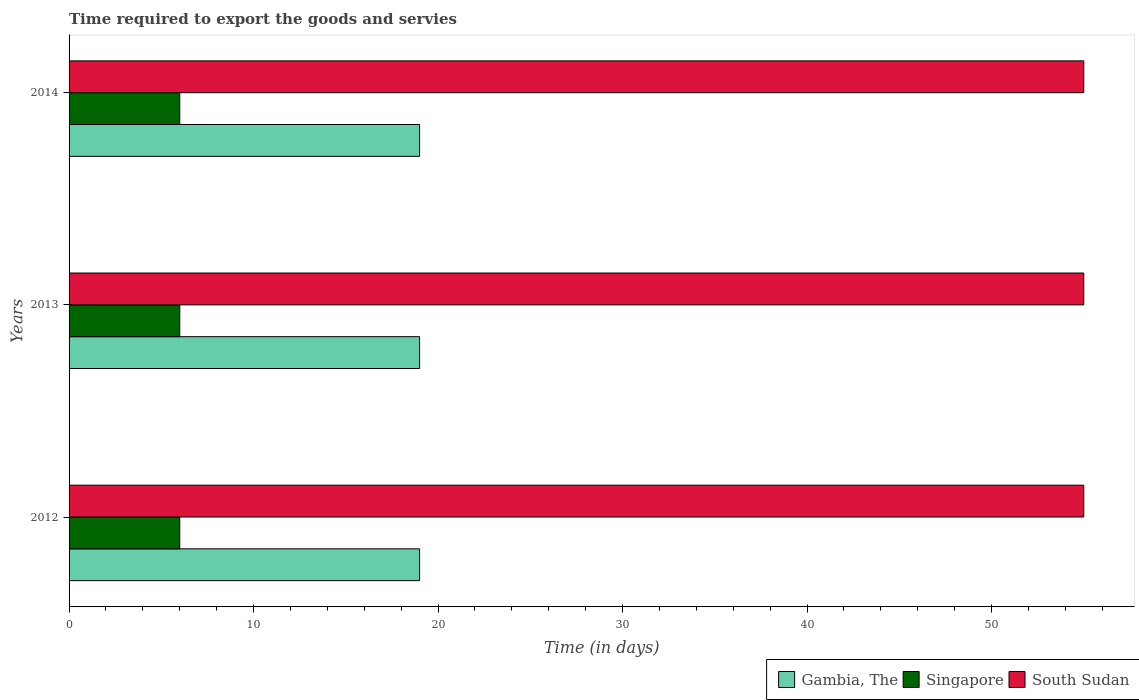How many different coloured bars are there?
Provide a succinct answer. 3. Are the number of bars per tick equal to the number of legend labels?
Give a very brief answer. Yes. Are the number of bars on each tick of the Y-axis equal?
Provide a succinct answer. Yes. How many bars are there on the 1st tick from the bottom?
Provide a short and direct response. 3. What is the label of the 2nd group of bars from the top?
Keep it short and to the point. 2013. What is the number of days required to export the goods and services in South Sudan in 2013?
Your response must be concise. 55. Across all years, what is the maximum number of days required to export the goods and services in Singapore?
Offer a very short reply. 6. Across all years, what is the minimum number of days required to export the goods and services in Singapore?
Keep it short and to the point. 6. In which year was the number of days required to export the goods and services in South Sudan maximum?
Offer a very short reply. 2012. What is the total number of days required to export the goods and services in Gambia, The in the graph?
Provide a short and direct response. 57. What is the difference between the number of days required to export the goods and services in Singapore in 2012 and that in 2013?
Your answer should be compact. 0. What is the difference between the number of days required to export the goods and services in Gambia, The in 2014 and the number of days required to export the goods and services in South Sudan in 2012?
Offer a very short reply. -36. In the year 2012, what is the difference between the number of days required to export the goods and services in Singapore and number of days required to export the goods and services in South Sudan?
Offer a terse response. -49. Is the number of days required to export the goods and services in Singapore in 2013 less than that in 2014?
Your response must be concise. No. What is the difference between the highest and the second highest number of days required to export the goods and services in Singapore?
Ensure brevity in your answer.  0. What is the difference between the highest and the lowest number of days required to export the goods and services in Singapore?
Make the answer very short. 0. What does the 1st bar from the top in 2014 represents?
Give a very brief answer. South Sudan. What does the 2nd bar from the bottom in 2012 represents?
Offer a very short reply. Singapore. Are all the bars in the graph horizontal?
Keep it short and to the point. Yes. How many years are there in the graph?
Give a very brief answer. 3. What is the difference between two consecutive major ticks on the X-axis?
Ensure brevity in your answer.  10. Are the values on the major ticks of X-axis written in scientific E-notation?
Ensure brevity in your answer.  No. Does the graph contain any zero values?
Ensure brevity in your answer.  No. Does the graph contain grids?
Offer a very short reply. No. How many legend labels are there?
Your answer should be compact. 3. How are the legend labels stacked?
Keep it short and to the point. Horizontal. What is the title of the graph?
Make the answer very short. Time required to export the goods and servies. Does "Mali" appear as one of the legend labels in the graph?
Your response must be concise. No. What is the label or title of the X-axis?
Offer a terse response. Time (in days). What is the label or title of the Y-axis?
Offer a terse response. Years. What is the Time (in days) of Singapore in 2012?
Ensure brevity in your answer.  6. What is the Time (in days) in South Sudan in 2012?
Your response must be concise. 55. What is the Time (in days) in Gambia, The in 2013?
Your answer should be compact. 19. What is the Time (in days) in South Sudan in 2013?
Offer a very short reply. 55. What is the Time (in days) in Gambia, The in 2014?
Offer a terse response. 19. What is the Time (in days) in South Sudan in 2014?
Offer a terse response. 55. Across all years, what is the maximum Time (in days) of Gambia, The?
Make the answer very short. 19. Across all years, what is the maximum Time (in days) of South Sudan?
Offer a terse response. 55. Across all years, what is the minimum Time (in days) in Singapore?
Provide a succinct answer. 6. Across all years, what is the minimum Time (in days) in South Sudan?
Your answer should be compact. 55. What is the total Time (in days) in South Sudan in the graph?
Your response must be concise. 165. What is the difference between the Time (in days) of Singapore in 2012 and that in 2013?
Give a very brief answer. 0. What is the difference between the Time (in days) of South Sudan in 2012 and that in 2013?
Make the answer very short. 0. What is the difference between the Time (in days) of Gambia, The in 2012 and that in 2014?
Your answer should be very brief. 0. What is the difference between the Time (in days) in Singapore in 2012 and that in 2014?
Your answer should be very brief. 0. What is the difference between the Time (in days) of South Sudan in 2013 and that in 2014?
Keep it short and to the point. 0. What is the difference between the Time (in days) of Gambia, The in 2012 and the Time (in days) of South Sudan in 2013?
Your answer should be very brief. -36. What is the difference between the Time (in days) of Singapore in 2012 and the Time (in days) of South Sudan in 2013?
Provide a succinct answer. -49. What is the difference between the Time (in days) in Gambia, The in 2012 and the Time (in days) in Singapore in 2014?
Give a very brief answer. 13. What is the difference between the Time (in days) in Gambia, The in 2012 and the Time (in days) in South Sudan in 2014?
Offer a terse response. -36. What is the difference between the Time (in days) of Singapore in 2012 and the Time (in days) of South Sudan in 2014?
Provide a succinct answer. -49. What is the difference between the Time (in days) in Gambia, The in 2013 and the Time (in days) in South Sudan in 2014?
Ensure brevity in your answer.  -36. What is the difference between the Time (in days) in Singapore in 2013 and the Time (in days) in South Sudan in 2014?
Offer a very short reply. -49. What is the average Time (in days) of Gambia, The per year?
Your response must be concise. 19. What is the average Time (in days) of Singapore per year?
Make the answer very short. 6. What is the average Time (in days) of South Sudan per year?
Offer a terse response. 55. In the year 2012, what is the difference between the Time (in days) in Gambia, The and Time (in days) in Singapore?
Make the answer very short. 13. In the year 2012, what is the difference between the Time (in days) of Gambia, The and Time (in days) of South Sudan?
Ensure brevity in your answer.  -36. In the year 2012, what is the difference between the Time (in days) of Singapore and Time (in days) of South Sudan?
Your response must be concise. -49. In the year 2013, what is the difference between the Time (in days) of Gambia, The and Time (in days) of South Sudan?
Your answer should be compact. -36. In the year 2013, what is the difference between the Time (in days) in Singapore and Time (in days) in South Sudan?
Your answer should be compact. -49. In the year 2014, what is the difference between the Time (in days) in Gambia, The and Time (in days) in South Sudan?
Your answer should be compact. -36. In the year 2014, what is the difference between the Time (in days) in Singapore and Time (in days) in South Sudan?
Make the answer very short. -49. What is the ratio of the Time (in days) of South Sudan in 2012 to that in 2013?
Offer a very short reply. 1. What is the ratio of the Time (in days) of Gambia, The in 2012 to that in 2014?
Give a very brief answer. 1. What is the ratio of the Time (in days) of Singapore in 2012 to that in 2014?
Offer a very short reply. 1. What is the ratio of the Time (in days) in South Sudan in 2012 to that in 2014?
Ensure brevity in your answer.  1. What is the ratio of the Time (in days) in Singapore in 2013 to that in 2014?
Your response must be concise. 1. What is the ratio of the Time (in days) in South Sudan in 2013 to that in 2014?
Your answer should be compact. 1. What is the difference between the highest and the second highest Time (in days) in Gambia, The?
Give a very brief answer. 0. What is the difference between the highest and the second highest Time (in days) in Singapore?
Provide a short and direct response. 0. What is the difference between the highest and the lowest Time (in days) in Gambia, The?
Offer a very short reply. 0. What is the difference between the highest and the lowest Time (in days) in South Sudan?
Your response must be concise. 0. 